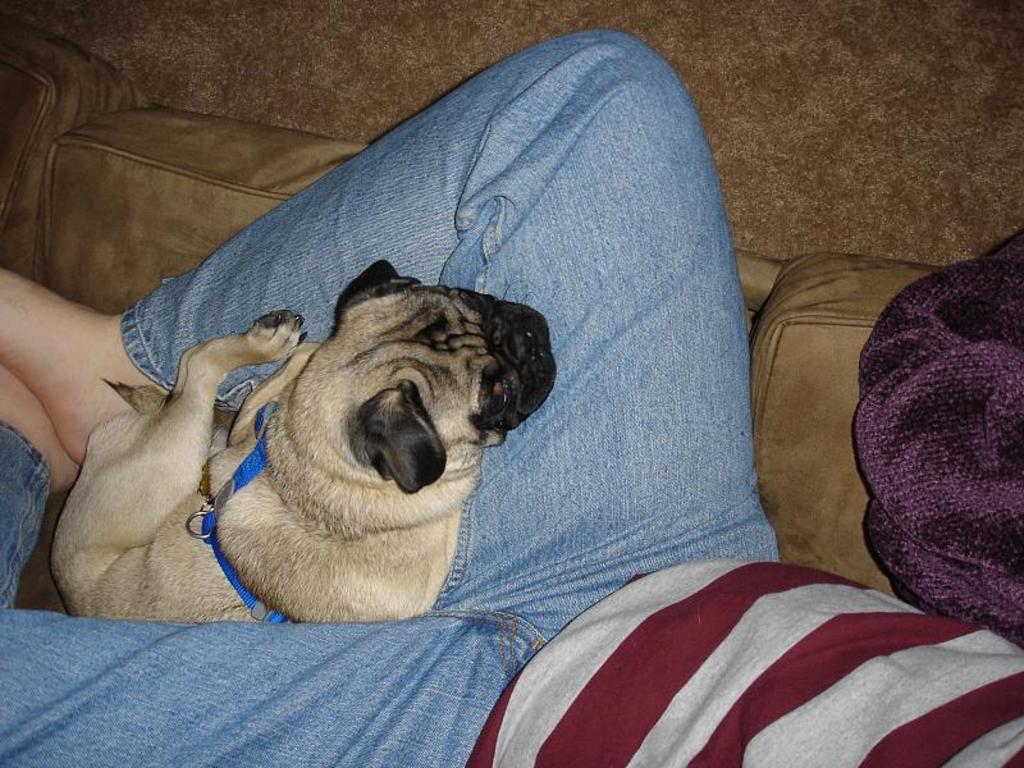Can you describe this image briefly? This is the picture of a dog which is on the person and the person is lying on the sofa. 